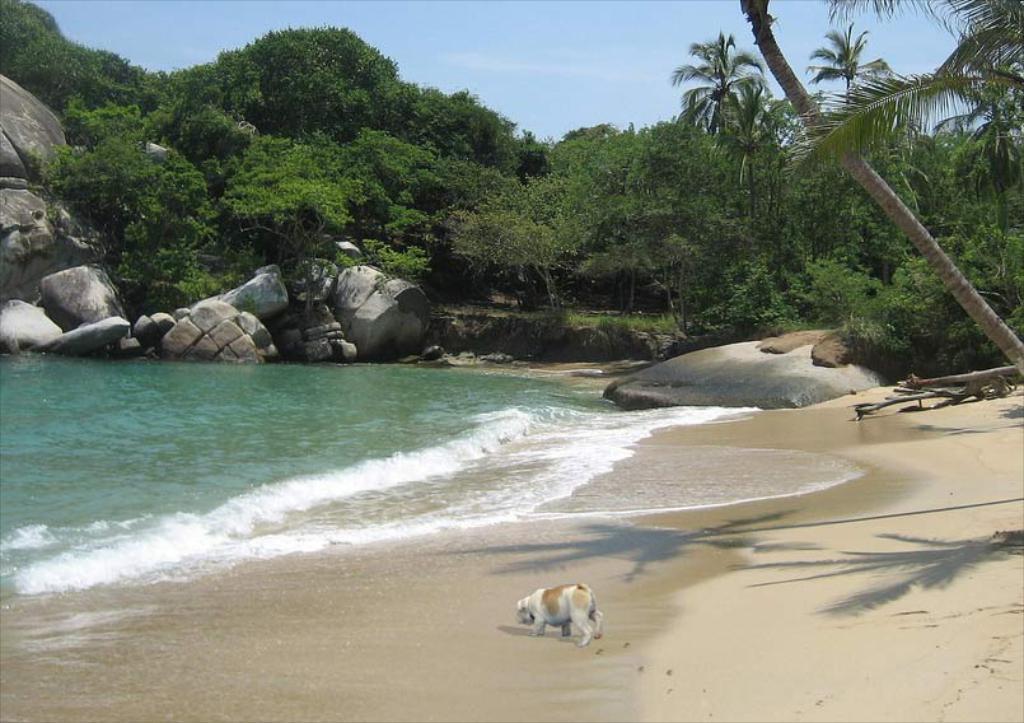Please provide a concise description of this image. In this image we can see a dog on the seashore and there are some rocks and we can see some trees and at the top we can see the sky. 